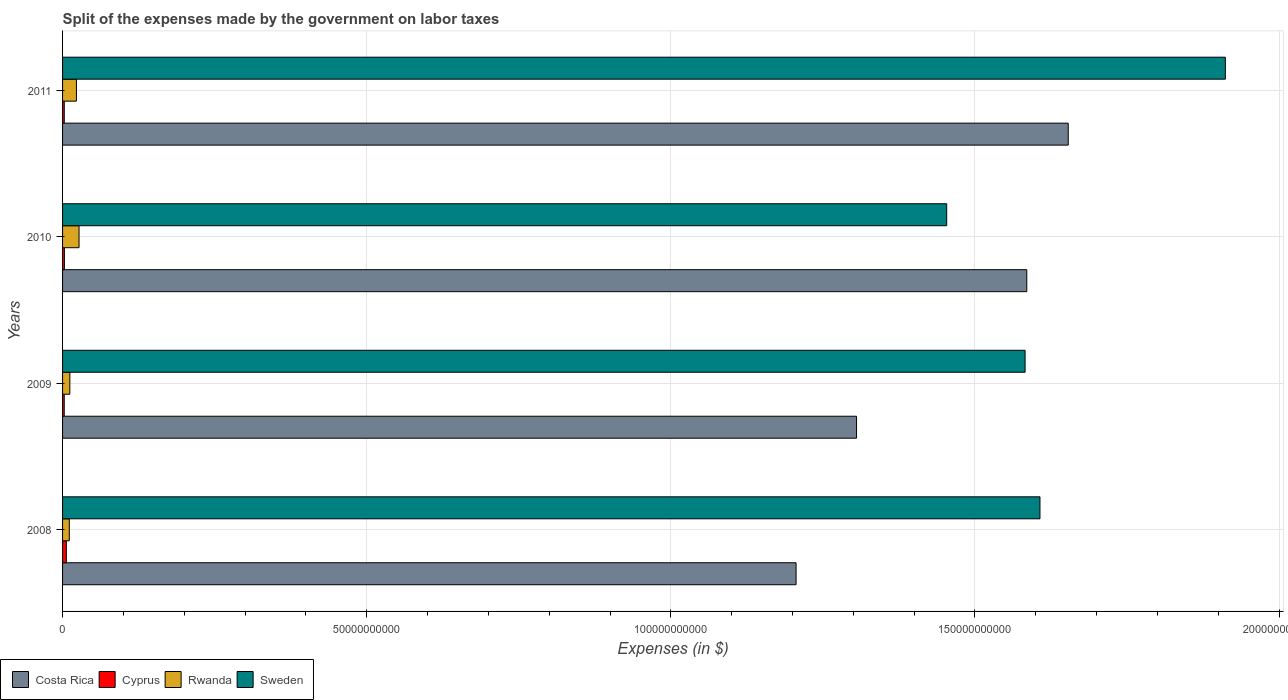How many groups of bars are there?
Provide a succinct answer. 4. Are the number of bars per tick equal to the number of legend labels?
Provide a succinct answer. Yes. How many bars are there on the 2nd tick from the top?
Make the answer very short. 4. How many bars are there on the 1st tick from the bottom?
Keep it short and to the point. 4. What is the label of the 2nd group of bars from the top?
Offer a terse response. 2010. What is the expenses made by the government on labor taxes in Rwanda in 2008?
Keep it short and to the point. 1.11e+09. Across all years, what is the maximum expenses made by the government on labor taxes in Costa Rica?
Your answer should be compact. 1.65e+11. Across all years, what is the minimum expenses made by the government on labor taxes in Costa Rica?
Your answer should be very brief. 1.21e+11. What is the total expenses made by the government on labor taxes in Rwanda in the graph?
Ensure brevity in your answer.  7.29e+09. What is the difference between the expenses made by the government on labor taxes in Cyprus in 2008 and that in 2010?
Ensure brevity in your answer.  3.18e+08. What is the difference between the expenses made by the government on labor taxes in Sweden in 2010 and the expenses made by the government on labor taxes in Cyprus in 2009?
Provide a short and direct response. 1.45e+11. What is the average expenses made by the government on labor taxes in Costa Rica per year?
Make the answer very short. 1.44e+11. In the year 2008, what is the difference between the expenses made by the government on labor taxes in Cyprus and expenses made by the government on labor taxes in Costa Rica?
Offer a terse response. -1.20e+11. In how many years, is the expenses made by the government on labor taxes in Cyprus greater than 80000000000 $?
Your answer should be very brief. 0. What is the ratio of the expenses made by the government on labor taxes in Sweden in 2009 to that in 2011?
Give a very brief answer. 0.83. Is the expenses made by the government on labor taxes in Costa Rica in 2008 less than that in 2010?
Provide a short and direct response. Yes. Is the difference between the expenses made by the government on labor taxes in Cyprus in 2010 and 2011 greater than the difference between the expenses made by the government on labor taxes in Costa Rica in 2010 and 2011?
Give a very brief answer. Yes. What is the difference between the highest and the second highest expenses made by the government on labor taxes in Rwanda?
Ensure brevity in your answer.  4.31e+08. What is the difference between the highest and the lowest expenses made by the government on labor taxes in Cyprus?
Ensure brevity in your answer.  3.47e+08. In how many years, is the expenses made by the government on labor taxes in Cyprus greater than the average expenses made by the government on labor taxes in Cyprus taken over all years?
Your answer should be compact. 1. Is the sum of the expenses made by the government on labor taxes in Sweden in 2009 and 2011 greater than the maximum expenses made by the government on labor taxes in Rwanda across all years?
Offer a very short reply. Yes. Is it the case that in every year, the sum of the expenses made by the government on labor taxes in Cyprus and expenses made by the government on labor taxes in Sweden is greater than the sum of expenses made by the government on labor taxes in Rwanda and expenses made by the government on labor taxes in Costa Rica?
Provide a succinct answer. No. Is it the case that in every year, the sum of the expenses made by the government on labor taxes in Costa Rica and expenses made by the government on labor taxes in Cyprus is greater than the expenses made by the government on labor taxes in Sweden?
Ensure brevity in your answer.  No. How many bars are there?
Provide a short and direct response. 16. Are all the bars in the graph horizontal?
Provide a short and direct response. Yes. Does the graph contain any zero values?
Ensure brevity in your answer.  No. Where does the legend appear in the graph?
Your response must be concise. Bottom left. What is the title of the graph?
Offer a terse response. Split of the expenses made by the government on labor taxes. What is the label or title of the X-axis?
Give a very brief answer. Expenses (in $). What is the label or title of the Y-axis?
Keep it short and to the point. Years. What is the Expenses (in $) in Costa Rica in 2008?
Offer a very short reply. 1.21e+11. What is the Expenses (in $) in Cyprus in 2008?
Provide a short and direct response. 6.21e+08. What is the Expenses (in $) of Rwanda in 2008?
Your answer should be compact. 1.11e+09. What is the Expenses (in $) in Sweden in 2008?
Provide a succinct answer. 1.61e+11. What is the Expenses (in $) in Costa Rica in 2009?
Keep it short and to the point. 1.31e+11. What is the Expenses (in $) of Cyprus in 2009?
Provide a succinct answer. 2.74e+08. What is the Expenses (in $) in Rwanda in 2009?
Give a very brief answer. 1.20e+09. What is the Expenses (in $) of Sweden in 2009?
Keep it short and to the point. 1.58e+11. What is the Expenses (in $) of Costa Rica in 2010?
Provide a short and direct response. 1.59e+11. What is the Expenses (in $) of Cyprus in 2010?
Your response must be concise. 3.02e+08. What is the Expenses (in $) of Rwanda in 2010?
Give a very brief answer. 2.71e+09. What is the Expenses (in $) of Sweden in 2010?
Offer a terse response. 1.45e+11. What is the Expenses (in $) in Costa Rica in 2011?
Make the answer very short. 1.65e+11. What is the Expenses (in $) in Cyprus in 2011?
Your answer should be very brief. 2.80e+08. What is the Expenses (in $) in Rwanda in 2011?
Give a very brief answer. 2.28e+09. What is the Expenses (in $) in Sweden in 2011?
Provide a succinct answer. 1.91e+11. Across all years, what is the maximum Expenses (in $) of Costa Rica?
Keep it short and to the point. 1.65e+11. Across all years, what is the maximum Expenses (in $) in Cyprus?
Your response must be concise. 6.21e+08. Across all years, what is the maximum Expenses (in $) of Rwanda?
Ensure brevity in your answer.  2.71e+09. Across all years, what is the maximum Expenses (in $) in Sweden?
Provide a succinct answer. 1.91e+11. Across all years, what is the minimum Expenses (in $) of Costa Rica?
Make the answer very short. 1.21e+11. Across all years, what is the minimum Expenses (in $) of Cyprus?
Your answer should be very brief. 2.74e+08. Across all years, what is the minimum Expenses (in $) of Rwanda?
Your response must be concise. 1.11e+09. Across all years, what is the minimum Expenses (in $) in Sweden?
Offer a very short reply. 1.45e+11. What is the total Expenses (in $) in Costa Rica in the graph?
Ensure brevity in your answer.  5.75e+11. What is the total Expenses (in $) in Cyprus in the graph?
Offer a very short reply. 1.48e+09. What is the total Expenses (in $) of Rwanda in the graph?
Give a very brief answer. 7.29e+09. What is the total Expenses (in $) in Sweden in the graph?
Ensure brevity in your answer.  6.55e+11. What is the difference between the Expenses (in $) in Costa Rica in 2008 and that in 2009?
Your response must be concise. -9.94e+09. What is the difference between the Expenses (in $) in Cyprus in 2008 and that in 2009?
Make the answer very short. 3.47e+08. What is the difference between the Expenses (in $) of Rwanda in 2008 and that in 2009?
Make the answer very short. -8.79e+07. What is the difference between the Expenses (in $) in Sweden in 2008 and that in 2009?
Provide a succinct answer. 2.45e+09. What is the difference between the Expenses (in $) in Costa Rica in 2008 and that in 2010?
Make the answer very short. -3.79e+1. What is the difference between the Expenses (in $) of Cyprus in 2008 and that in 2010?
Ensure brevity in your answer.  3.18e+08. What is the difference between the Expenses (in $) in Rwanda in 2008 and that in 2010?
Your response must be concise. -1.60e+09. What is the difference between the Expenses (in $) in Sweden in 2008 and that in 2010?
Ensure brevity in your answer.  1.53e+1. What is the difference between the Expenses (in $) in Costa Rica in 2008 and that in 2011?
Your response must be concise. -4.47e+1. What is the difference between the Expenses (in $) in Cyprus in 2008 and that in 2011?
Provide a succinct answer. 3.41e+08. What is the difference between the Expenses (in $) of Rwanda in 2008 and that in 2011?
Provide a succinct answer. -1.17e+09. What is the difference between the Expenses (in $) in Sweden in 2008 and that in 2011?
Your response must be concise. -3.05e+1. What is the difference between the Expenses (in $) in Costa Rica in 2009 and that in 2010?
Your response must be concise. -2.80e+1. What is the difference between the Expenses (in $) in Cyprus in 2009 and that in 2010?
Provide a succinct answer. -2.84e+07. What is the difference between the Expenses (in $) of Rwanda in 2009 and that in 2010?
Your answer should be very brief. -1.51e+09. What is the difference between the Expenses (in $) in Sweden in 2009 and that in 2010?
Make the answer very short. 1.29e+1. What is the difference between the Expenses (in $) in Costa Rica in 2009 and that in 2011?
Keep it short and to the point. -3.48e+1. What is the difference between the Expenses (in $) of Cyprus in 2009 and that in 2011?
Offer a very short reply. -6.00e+06. What is the difference between the Expenses (in $) of Rwanda in 2009 and that in 2011?
Ensure brevity in your answer.  -1.08e+09. What is the difference between the Expenses (in $) of Sweden in 2009 and that in 2011?
Your answer should be very brief. -3.29e+1. What is the difference between the Expenses (in $) of Costa Rica in 2010 and that in 2011?
Ensure brevity in your answer.  -6.81e+09. What is the difference between the Expenses (in $) of Cyprus in 2010 and that in 2011?
Keep it short and to the point. 2.24e+07. What is the difference between the Expenses (in $) of Rwanda in 2010 and that in 2011?
Provide a succinct answer. 4.31e+08. What is the difference between the Expenses (in $) of Sweden in 2010 and that in 2011?
Provide a succinct answer. -4.58e+1. What is the difference between the Expenses (in $) of Costa Rica in 2008 and the Expenses (in $) of Cyprus in 2009?
Provide a succinct answer. 1.20e+11. What is the difference between the Expenses (in $) in Costa Rica in 2008 and the Expenses (in $) in Rwanda in 2009?
Keep it short and to the point. 1.19e+11. What is the difference between the Expenses (in $) of Costa Rica in 2008 and the Expenses (in $) of Sweden in 2009?
Offer a terse response. -3.76e+1. What is the difference between the Expenses (in $) in Cyprus in 2008 and the Expenses (in $) in Rwanda in 2009?
Offer a terse response. -5.74e+08. What is the difference between the Expenses (in $) of Cyprus in 2008 and the Expenses (in $) of Sweden in 2009?
Your answer should be compact. -1.58e+11. What is the difference between the Expenses (in $) in Rwanda in 2008 and the Expenses (in $) in Sweden in 2009?
Your response must be concise. -1.57e+11. What is the difference between the Expenses (in $) of Costa Rica in 2008 and the Expenses (in $) of Cyprus in 2010?
Offer a terse response. 1.20e+11. What is the difference between the Expenses (in $) of Costa Rica in 2008 and the Expenses (in $) of Rwanda in 2010?
Keep it short and to the point. 1.18e+11. What is the difference between the Expenses (in $) in Costa Rica in 2008 and the Expenses (in $) in Sweden in 2010?
Provide a succinct answer. -2.48e+1. What is the difference between the Expenses (in $) of Cyprus in 2008 and the Expenses (in $) of Rwanda in 2010?
Keep it short and to the point. -2.09e+09. What is the difference between the Expenses (in $) in Cyprus in 2008 and the Expenses (in $) in Sweden in 2010?
Make the answer very short. -1.45e+11. What is the difference between the Expenses (in $) of Rwanda in 2008 and the Expenses (in $) of Sweden in 2010?
Offer a very short reply. -1.44e+11. What is the difference between the Expenses (in $) of Costa Rica in 2008 and the Expenses (in $) of Cyprus in 2011?
Your response must be concise. 1.20e+11. What is the difference between the Expenses (in $) of Costa Rica in 2008 and the Expenses (in $) of Rwanda in 2011?
Provide a succinct answer. 1.18e+11. What is the difference between the Expenses (in $) of Costa Rica in 2008 and the Expenses (in $) of Sweden in 2011?
Offer a very short reply. -7.06e+1. What is the difference between the Expenses (in $) of Cyprus in 2008 and the Expenses (in $) of Rwanda in 2011?
Offer a very short reply. -1.66e+09. What is the difference between the Expenses (in $) of Cyprus in 2008 and the Expenses (in $) of Sweden in 2011?
Ensure brevity in your answer.  -1.91e+11. What is the difference between the Expenses (in $) of Rwanda in 2008 and the Expenses (in $) of Sweden in 2011?
Ensure brevity in your answer.  -1.90e+11. What is the difference between the Expenses (in $) of Costa Rica in 2009 and the Expenses (in $) of Cyprus in 2010?
Offer a terse response. 1.30e+11. What is the difference between the Expenses (in $) in Costa Rica in 2009 and the Expenses (in $) in Rwanda in 2010?
Make the answer very short. 1.28e+11. What is the difference between the Expenses (in $) in Costa Rica in 2009 and the Expenses (in $) in Sweden in 2010?
Ensure brevity in your answer.  -1.48e+1. What is the difference between the Expenses (in $) in Cyprus in 2009 and the Expenses (in $) in Rwanda in 2010?
Keep it short and to the point. -2.43e+09. What is the difference between the Expenses (in $) of Cyprus in 2009 and the Expenses (in $) of Sweden in 2010?
Your answer should be very brief. -1.45e+11. What is the difference between the Expenses (in $) of Rwanda in 2009 and the Expenses (in $) of Sweden in 2010?
Provide a short and direct response. -1.44e+11. What is the difference between the Expenses (in $) of Costa Rica in 2009 and the Expenses (in $) of Cyprus in 2011?
Keep it short and to the point. 1.30e+11. What is the difference between the Expenses (in $) in Costa Rica in 2009 and the Expenses (in $) in Rwanda in 2011?
Offer a very short reply. 1.28e+11. What is the difference between the Expenses (in $) of Costa Rica in 2009 and the Expenses (in $) of Sweden in 2011?
Ensure brevity in your answer.  -6.06e+1. What is the difference between the Expenses (in $) of Cyprus in 2009 and the Expenses (in $) of Rwanda in 2011?
Ensure brevity in your answer.  -2.00e+09. What is the difference between the Expenses (in $) of Cyprus in 2009 and the Expenses (in $) of Sweden in 2011?
Keep it short and to the point. -1.91e+11. What is the difference between the Expenses (in $) in Rwanda in 2009 and the Expenses (in $) in Sweden in 2011?
Ensure brevity in your answer.  -1.90e+11. What is the difference between the Expenses (in $) in Costa Rica in 2010 and the Expenses (in $) in Cyprus in 2011?
Provide a succinct answer. 1.58e+11. What is the difference between the Expenses (in $) in Costa Rica in 2010 and the Expenses (in $) in Rwanda in 2011?
Give a very brief answer. 1.56e+11. What is the difference between the Expenses (in $) in Costa Rica in 2010 and the Expenses (in $) in Sweden in 2011?
Provide a short and direct response. -3.26e+1. What is the difference between the Expenses (in $) of Cyprus in 2010 and the Expenses (in $) of Rwanda in 2011?
Ensure brevity in your answer.  -1.98e+09. What is the difference between the Expenses (in $) of Cyprus in 2010 and the Expenses (in $) of Sweden in 2011?
Offer a very short reply. -1.91e+11. What is the difference between the Expenses (in $) in Rwanda in 2010 and the Expenses (in $) in Sweden in 2011?
Provide a short and direct response. -1.88e+11. What is the average Expenses (in $) in Costa Rica per year?
Your answer should be compact. 1.44e+11. What is the average Expenses (in $) in Cyprus per year?
Ensure brevity in your answer.  3.69e+08. What is the average Expenses (in $) of Rwanda per year?
Offer a terse response. 1.82e+09. What is the average Expenses (in $) of Sweden per year?
Keep it short and to the point. 1.64e+11. In the year 2008, what is the difference between the Expenses (in $) of Costa Rica and Expenses (in $) of Cyprus?
Keep it short and to the point. 1.20e+11. In the year 2008, what is the difference between the Expenses (in $) in Costa Rica and Expenses (in $) in Rwanda?
Provide a short and direct response. 1.19e+11. In the year 2008, what is the difference between the Expenses (in $) in Costa Rica and Expenses (in $) in Sweden?
Make the answer very short. -4.01e+1. In the year 2008, what is the difference between the Expenses (in $) of Cyprus and Expenses (in $) of Rwanda?
Offer a very short reply. -4.87e+08. In the year 2008, what is the difference between the Expenses (in $) of Cyprus and Expenses (in $) of Sweden?
Offer a very short reply. -1.60e+11. In the year 2008, what is the difference between the Expenses (in $) in Rwanda and Expenses (in $) in Sweden?
Keep it short and to the point. -1.60e+11. In the year 2009, what is the difference between the Expenses (in $) of Costa Rica and Expenses (in $) of Cyprus?
Provide a short and direct response. 1.30e+11. In the year 2009, what is the difference between the Expenses (in $) in Costa Rica and Expenses (in $) in Rwanda?
Provide a succinct answer. 1.29e+11. In the year 2009, what is the difference between the Expenses (in $) in Costa Rica and Expenses (in $) in Sweden?
Ensure brevity in your answer.  -2.77e+1. In the year 2009, what is the difference between the Expenses (in $) of Cyprus and Expenses (in $) of Rwanda?
Make the answer very short. -9.21e+08. In the year 2009, what is the difference between the Expenses (in $) in Cyprus and Expenses (in $) in Sweden?
Your answer should be compact. -1.58e+11. In the year 2009, what is the difference between the Expenses (in $) in Rwanda and Expenses (in $) in Sweden?
Provide a succinct answer. -1.57e+11. In the year 2010, what is the difference between the Expenses (in $) of Costa Rica and Expenses (in $) of Cyprus?
Keep it short and to the point. 1.58e+11. In the year 2010, what is the difference between the Expenses (in $) in Costa Rica and Expenses (in $) in Rwanda?
Offer a terse response. 1.56e+11. In the year 2010, what is the difference between the Expenses (in $) of Costa Rica and Expenses (in $) of Sweden?
Provide a succinct answer. 1.32e+1. In the year 2010, what is the difference between the Expenses (in $) of Cyprus and Expenses (in $) of Rwanda?
Offer a terse response. -2.41e+09. In the year 2010, what is the difference between the Expenses (in $) of Cyprus and Expenses (in $) of Sweden?
Your answer should be very brief. -1.45e+11. In the year 2010, what is the difference between the Expenses (in $) in Rwanda and Expenses (in $) in Sweden?
Your answer should be very brief. -1.43e+11. In the year 2011, what is the difference between the Expenses (in $) in Costa Rica and Expenses (in $) in Cyprus?
Your answer should be very brief. 1.65e+11. In the year 2011, what is the difference between the Expenses (in $) of Costa Rica and Expenses (in $) of Rwanda?
Keep it short and to the point. 1.63e+11. In the year 2011, what is the difference between the Expenses (in $) of Costa Rica and Expenses (in $) of Sweden?
Make the answer very short. -2.58e+1. In the year 2011, what is the difference between the Expenses (in $) in Cyprus and Expenses (in $) in Rwanda?
Your answer should be compact. -2.00e+09. In the year 2011, what is the difference between the Expenses (in $) of Cyprus and Expenses (in $) of Sweden?
Make the answer very short. -1.91e+11. In the year 2011, what is the difference between the Expenses (in $) in Rwanda and Expenses (in $) in Sweden?
Your response must be concise. -1.89e+11. What is the ratio of the Expenses (in $) of Costa Rica in 2008 to that in 2009?
Your answer should be compact. 0.92. What is the ratio of the Expenses (in $) in Cyprus in 2008 to that in 2009?
Ensure brevity in your answer.  2.27. What is the ratio of the Expenses (in $) of Rwanda in 2008 to that in 2009?
Ensure brevity in your answer.  0.93. What is the ratio of the Expenses (in $) of Sweden in 2008 to that in 2009?
Your answer should be compact. 1.02. What is the ratio of the Expenses (in $) of Costa Rica in 2008 to that in 2010?
Ensure brevity in your answer.  0.76. What is the ratio of the Expenses (in $) in Cyprus in 2008 to that in 2010?
Offer a terse response. 2.05. What is the ratio of the Expenses (in $) of Rwanda in 2008 to that in 2010?
Offer a terse response. 0.41. What is the ratio of the Expenses (in $) of Sweden in 2008 to that in 2010?
Give a very brief answer. 1.11. What is the ratio of the Expenses (in $) in Costa Rica in 2008 to that in 2011?
Give a very brief answer. 0.73. What is the ratio of the Expenses (in $) of Cyprus in 2008 to that in 2011?
Your response must be concise. 2.22. What is the ratio of the Expenses (in $) of Rwanda in 2008 to that in 2011?
Your response must be concise. 0.49. What is the ratio of the Expenses (in $) of Sweden in 2008 to that in 2011?
Provide a succinct answer. 0.84. What is the ratio of the Expenses (in $) of Costa Rica in 2009 to that in 2010?
Offer a very short reply. 0.82. What is the ratio of the Expenses (in $) in Cyprus in 2009 to that in 2010?
Provide a short and direct response. 0.91. What is the ratio of the Expenses (in $) in Rwanda in 2009 to that in 2010?
Give a very brief answer. 0.44. What is the ratio of the Expenses (in $) in Sweden in 2009 to that in 2010?
Keep it short and to the point. 1.09. What is the ratio of the Expenses (in $) in Costa Rica in 2009 to that in 2011?
Your response must be concise. 0.79. What is the ratio of the Expenses (in $) in Cyprus in 2009 to that in 2011?
Give a very brief answer. 0.98. What is the ratio of the Expenses (in $) in Rwanda in 2009 to that in 2011?
Your answer should be compact. 0.52. What is the ratio of the Expenses (in $) in Sweden in 2009 to that in 2011?
Your response must be concise. 0.83. What is the ratio of the Expenses (in $) in Costa Rica in 2010 to that in 2011?
Your answer should be very brief. 0.96. What is the ratio of the Expenses (in $) of Rwanda in 2010 to that in 2011?
Offer a very short reply. 1.19. What is the ratio of the Expenses (in $) in Sweden in 2010 to that in 2011?
Offer a very short reply. 0.76. What is the difference between the highest and the second highest Expenses (in $) in Costa Rica?
Offer a terse response. 6.81e+09. What is the difference between the highest and the second highest Expenses (in $) of Cyprus?
Offer a very short reply. 3.18e+08. What is the difference between the highest and the second highest Expenses (in $) in Rwanda?
Provide a succinct answer. 4.31e+08. What is the difference between the highest and the second highest Expenses (in $) in Sweden?
Ensure brevity in your answer.  3.05e+1. What is the difference between the highest and the lowest Expenses (in $) in Costa Rica?
Offer a terse response. 4.47e+1. What is the difference between the highest and the lowest Expenses (in $) of Cyprus?
Provide a short and direct response. 3.47e+08. What is the difference between the highest and the lowest Expenses (in $) in Rwanda?
Your answer should be very brief. 1.60e+09. What is the difference between the highest and the lowest Expenses (in $) of Sweden?
Keep it short and to the point. 4.58e+1. 